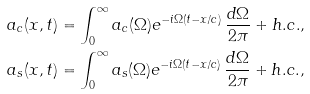<formula> <loc_0><loc_0><loc_500><loc_500>a _ { c } ( x , t ) & = \int _ { 0 } ^ { \infty } a _ { c } ( \Omega ) e ^ { - i \Omega ( t - x / c ) } \, \frac { d \Omega } { 2 \pi } + { h . c . } , \\ a _ { s } ( x , t ) & = \int _ { 0 } ^ { \infty } a _ { s } ( \Omega ) e ^ { - i \Omega ( t - x / c ) } \, \frac { d \Omega } { 2 \pi } + { h . c . } ,</formula> 